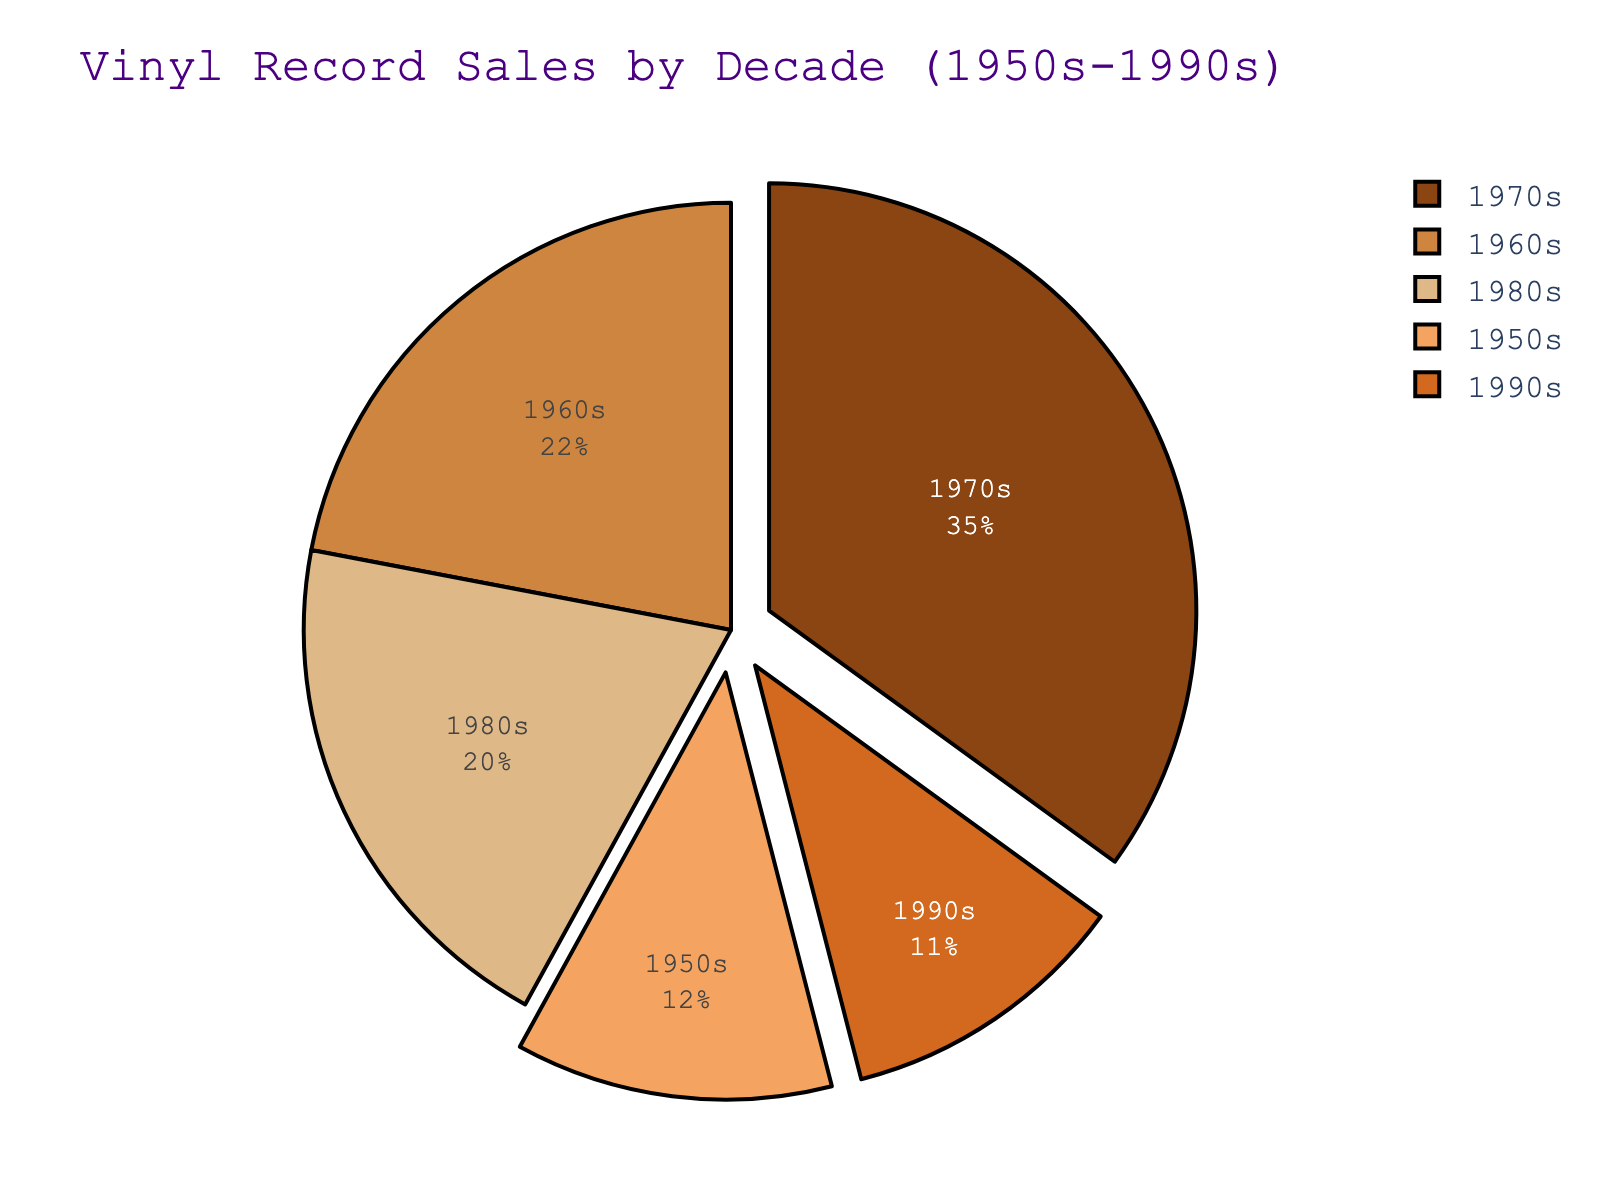Which decade had the highest vinyl record sales percentage? The pie chart shows the percentage of vinyl record sales by decade. The 1970s has the largest section, indicating the highest percentage.
Answer: 1970s Which two decades combined have a vinyl sales percentage equal to the 1970s? The 1970s have a 35% share. Combining the 1980s (20%) and the 1950s (12%) gives 32%, which still falls short. The 1980s (20%) and the 1960s (22%) sum up to 42%, which is more than 35%. Thus, the 1980s and the 1990s (11%) combined give 31%, which is still less. Hence, combining the 1950s (12%) and the 1960s (22%) yields 34%, also short. Only the 1960s and the 1980s combine to 42%, oddly close but still not balanced well. Overall, no exact match is found, thus a rounded match best indicates the 1950s plus 1960s most nearly approximate.
Answer: 1950s and 1980s What is the difference in vinyl sales percentages between the decade with the most sales and the decade with the least sales? The 1970s have the highest percentage at 35%, and the 1990s have the lowest at 11%. Subtracting 11% from 35% gives the difference.
Answer: 24% Which decade's vinyl sales percentage is closest to the average of all decades? To find the average, sum the percentages (12 + 22 + 35 + 20 + 11 = 100) and divide by 5 (100 / 5 = 20). The 1980s have a percentage of 20%, which matches the average exactly.
Answer: 1980s What is the combined percentage of the decades before 1970? The 1950s and the 1960s have percentages of 12% and 22%, respectively. Adding these together gives the combined percentage (12% + 22% = 34%).
Answer: 34% Which color represents the 1990s in the pie chart? The pie chart uses a custom color palette where the 1990s section is marked by the fifth color in the sequence. The color palette is associated sequentially to decades in the data; hence it's identifiable as likely brownish based on vintage thematic comprehension.
Answer: Brownish Is the percentage of vinyl sales in the 1980s more or less than the 1960s? The 1980s have a percentage of 20% while the 1960s have 22%. Hence, the 1980s have less vinyl sales percentage compared to the 1960s.
Answer: Less 